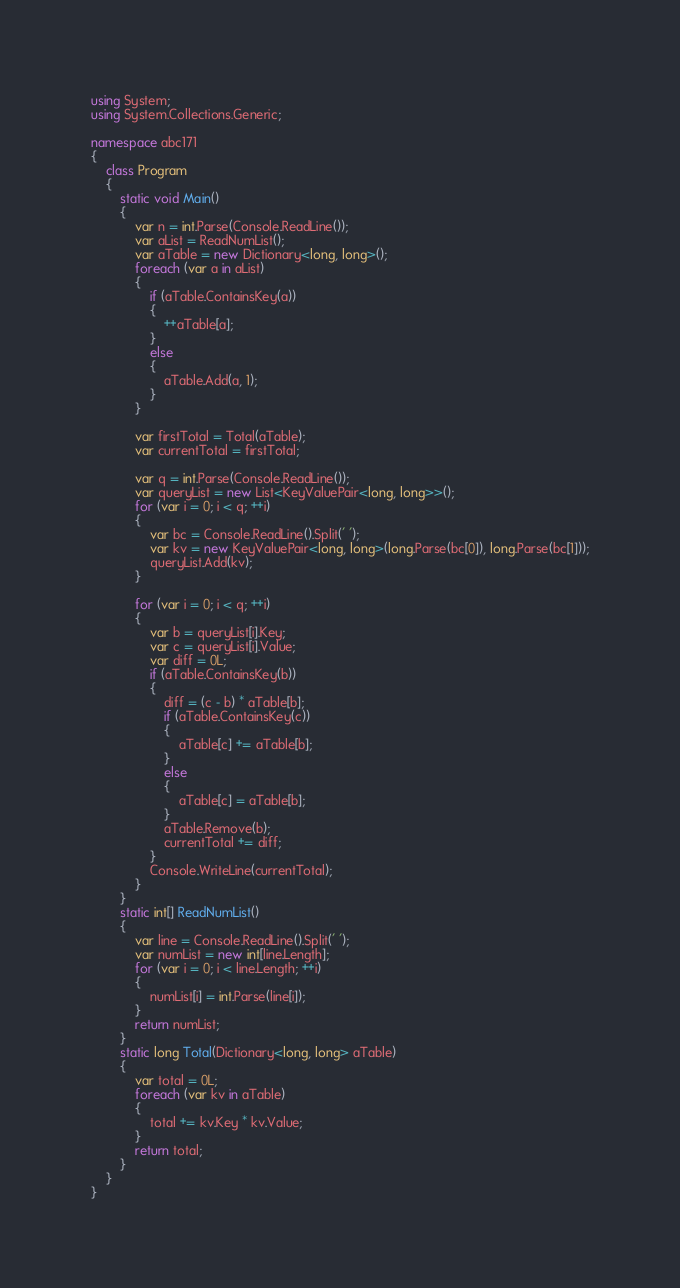Convert code to text. <code><loc_0><loc_0><loc_500><loc_500><_C#_>using System;
using System.Collections.Generic;

namespace abc171
{
    class Program
    {
        static void Main()
        {
            var n = int.Parse(Console.ReadLine());
            var aList = ReadNumList();
            var aTable = new Dictionary<long, long>();
            foreach (var a in aList)
            {
                if (aTable.ContainsKey(a))
                {
                    ++aTable[a];
                }
                else
                {
                    aTable.Add(a, 1);
                }
            }

            var firstTotal = Total(aTable);
            var currentTotal = firstTotal;

            var q = int.Parse(Console.ReadLine());
            var queryList = new List<KeyValuePair<long, long>>();
            for (var i = 0; i < q; ++i)
            {
                var bc = Console.ReadLine().Split(' ');
                var kv = new KeyValuePair<long, long>(long.Parse(bc[0]), long.Parse(bc[1]));
                queryList.Add(kv);
            }

            for (var i = 0; i < q; ++i)
            {
                var b = queryList[i].Key;
                var c = queryList[i].Value;
                var diff = 0L;
                if (aTable.ContainsKey(b))
                {
                    diff = (c - b) * aTable[b];
                    if (aTable.ContainsKey(c))
                    {
                        aTable[c] += aTable[b];
                    }
                    else
                    {
                        aTable[c] = aTable[b];
                    }
                    aTable.Remove(b);
                    currentTotal += diff;
                }
                Console.WriteLine(currentTotal);
            }
        }
        static int[] ReadNumList()
        {
            var line = Console.ReadLine().Split(' ');
            var numList = new int[line.Length];
            for (var i = 0; i < line.Length; ++i)
            {
                numList[i] = int.Parse(line[i]);
            }
            return numList;
        }
        static long Total(Dictionary<long, long> aTable)
        {
            var total = 0L;
            foreach (var kv in aTable)
            {
                total += kv.Key * kv.Value;
            }
            return total;
        }
    }
}
</code> 